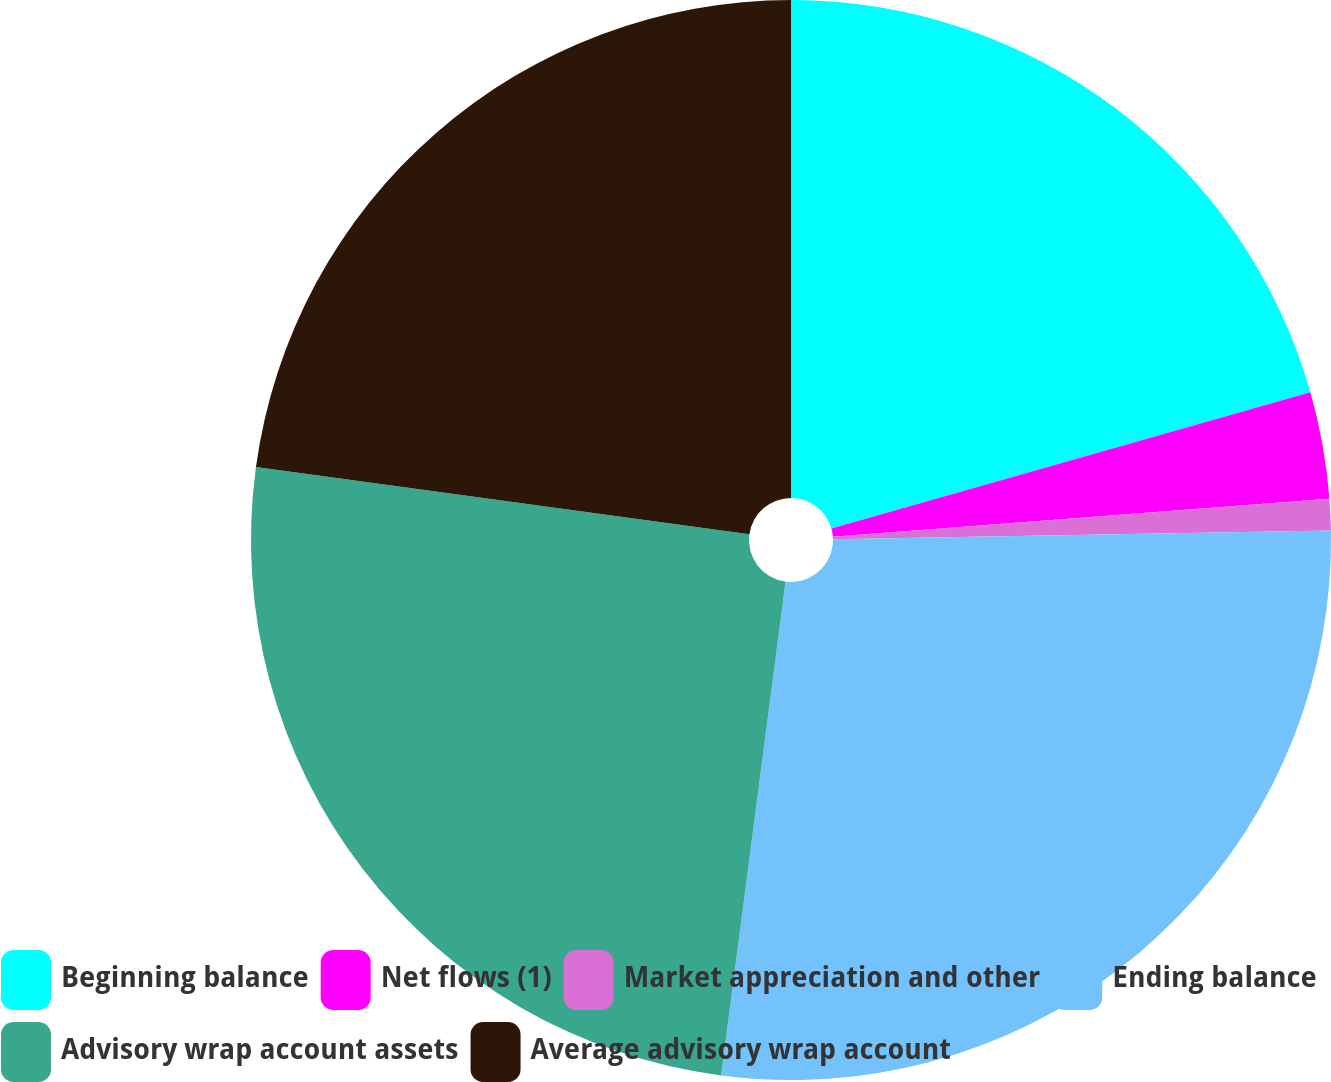Convert chart to OTSL. <chart><loc_0><loc_0><loc_500><loc_500><pie_chart><fcel>Beginning balance<fcel>Net flows (1)<fcel>Market appreciation and other<fcel>Ending balance<fcel>Advisory wrap account assets<fcel>Average advisory wrap account<nl><fcel>20.59%<fcel>3.19%<fcel>0.94%<fcel>27.34%<fcel>25.09%<fcel>22.84%<nl></chart> 